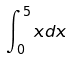Convert formula to latex. <formula><loc_0><loc_0><loc_500><loc_500>\int _ { 0 } ^ { 5 } x d x</formula> 